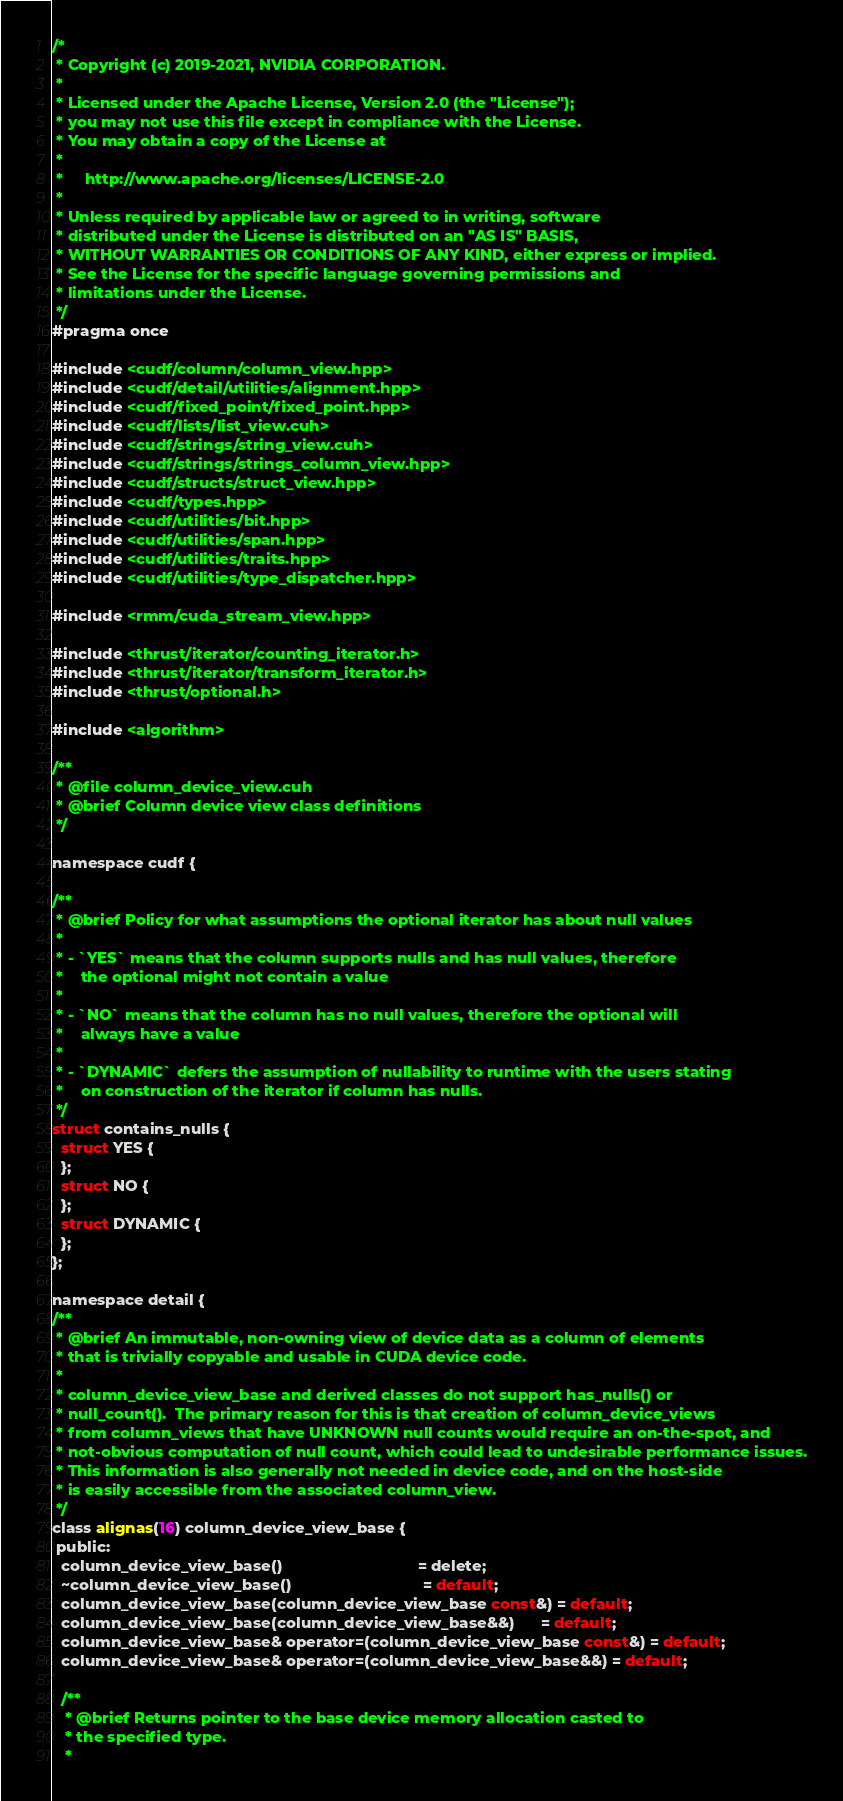<code> <loc_0><loc_0><loc_500><loc_500><_Cuda_>/*
 * Copyright (c) 2019-2021, NVIDIA CORPORATION.
 *
 * Licensed under the Apache License, Version 2.0 (the "License");
 * you may not use this file except in compliance with the License.
 * You may obtain a copy of the License at
 *
 *     http://www.apache.org/licenses/LICENSE-2.0
 *
 * Unless required by applicable law or agreed to in writing, software
 * distributed under the License is distributed on an "AS IS" BASIS,
 * WITHOUT WARRANTIES OR CONDITIONS OF ANY KIND, either express or implied.
 * See the License for the specific language governing permissions and
 * limitations under the License.
 */
#pragma once

#include <cudf/column/column_view.hpp>
#include <cudf/detail/utilities/alignment.hpp>
#include <cudf/fixed_point/fixed_point.hpp>
#include <cudf/lists/list_view.cuh>
#include <cudf/strings/string_view.cuh>
#include <cudf/strings/strings_column_view.hpp>
#include <cudf/structs/struct_view.hpp>
#include <cudf/types.hpp>
#include <cudf/utilities/bit.hpp>
#include <cudf/utilities/span.hpp>
#include <cudf/utilities/traits.hpp>
#include <cudf/utilities/type_dispatcher.hpp>

#include <rmm/cuda_stream_view.hpp>

#include <thrust/iterator/counting_iterator.h>
#include <thrust/iterator/transform_iterator.h>
#include <thrust/optional.h>

#include <algorithm>

/**
 * @file column_device_view.cuh
 * @brief Column device view class definitions
 */

namespace cudf {

/**
 * @brief Policy for what assumptions the optional iterator has about null values
 *
 * - `YES` means that the column supports nulls and has null values, therefore
 *    the optional might not contain a value
 *
 * - `NO` means that the column has no null values, therefore the optional will
 *    always have a value
 *
 * - `DYNAMIC` defers the assumption of nullability to runtime with the users stating
 *    on construction of the iterator if column has nulls.
 */
struct contains_nulls {
  struct YES {
  };
  struct NO {
  };
  struct DYNAMIC {
  };
};

namespace detail {
/**
 * @brief An immutable, non-owning view of device data as a column of elements
 * that is trivially copyable and usable in CUDA device code.
 *
 * column_device_view_base and derived classes do not support has_nulls() or
 * null_count().  The primary reason for this is that creation of column_device_views
 * from column_views that have UNKNOWN null counts would require an on-the-spot, and
 * not-obvious computation of null count, which could lead to undesirable performance issues.
 * This information is also generally not needed in device code, and on the host-side
 * is easily accessible from the associated column_view.
 */
class alignas(16) column_device_view_base {
 public:
  column_device_view_base()                               = delete;
  ~column_device_view_base()                              = default;
  column_device_view_base(column_device_view_base const&) = default;
  column_device_view_base(column_device_view_base&&)      = default;
  column_device_view_base& operator=(column_device_view_base const&) = default;
  column_device_view_base& operator=(column_device_view_base&&) = default;

  /**
   * @brief Returns pointer to the base device memory allocation casted to
   * the specified type.
   *</code> 